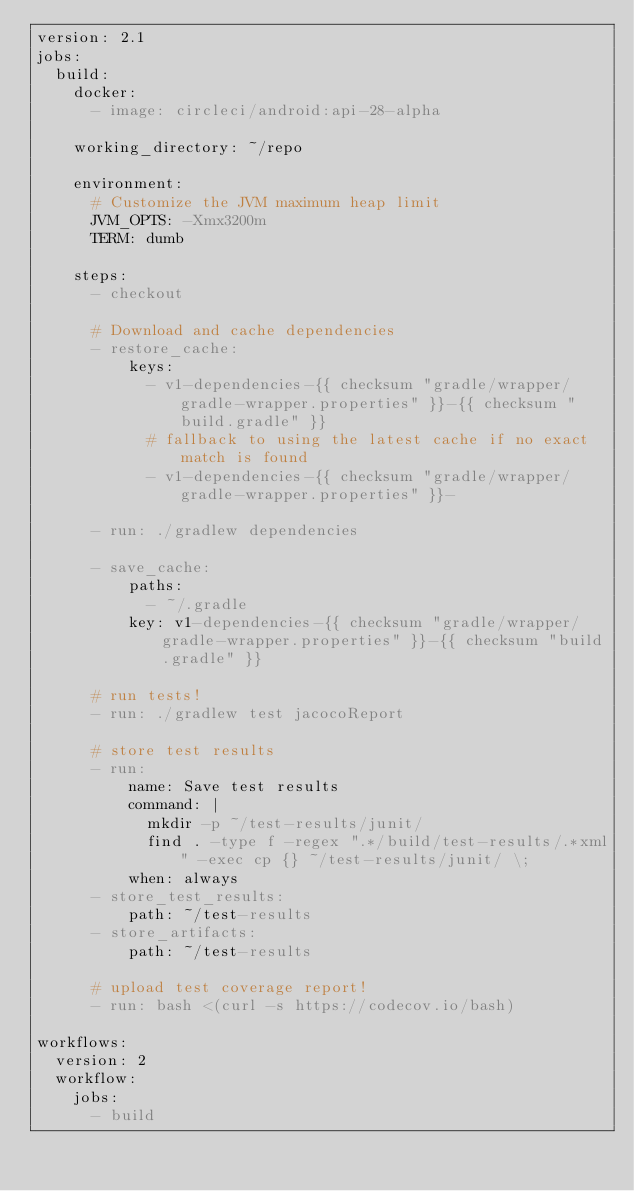<code> <loc_0><loc_0><loc_500><loc_500><_YAML_>version: 2.1
jobs:
  build:
    docker:
      - image: circleci/android:api-28-alpha

    working_directory: ~/repo

    environment:
      # Customize the JVM maximum heap limit
      JVM_OPTS: -Xmx3200m
      TERM: dumb

    steps:
      - checkout

      # Download and cache dependencies
      - restore_cache:
          keys:
            - v1-dependencies-{{ checksum "gradle/wrapper/gradle-wrapper.properties" }}-{{ checksum "build.gradle" }}
            # fallback to using the latest cache if no exact match is found
            - v1-dependencies-{{ checksum "gradle/wrapper/gradle-wrapper.properties" }}-

      - run: ./gradlew dependencies

      - save_cache:
          paths:
            - ~/.gradle
          key: v1-dependencies-{{ checksum "gradle/wrapper/gradle-wrapper.properties" }}-{{ checksum "build.gradle" }}

      # run tests!
      - run: ./gradlew test jacocoReport

      # store test results
      - run:
          name: Save test results
          command: |
            mkdir -p ~/test-results/junit/
            find . -type f -regex ".*/build/test-results/.*xml" -exec cp {} ~/test-results/junit/ \;
          when: always
      - store_test_results:
          path: ~/test-results
      - store_artifacts:
          path: ~/test-results

      # upload test coverage report!
      - run: bash <(curl -s https://codecov.io/bash)

workflows:
  version: 2
  workflow:
    jobs:
      - build</code> 